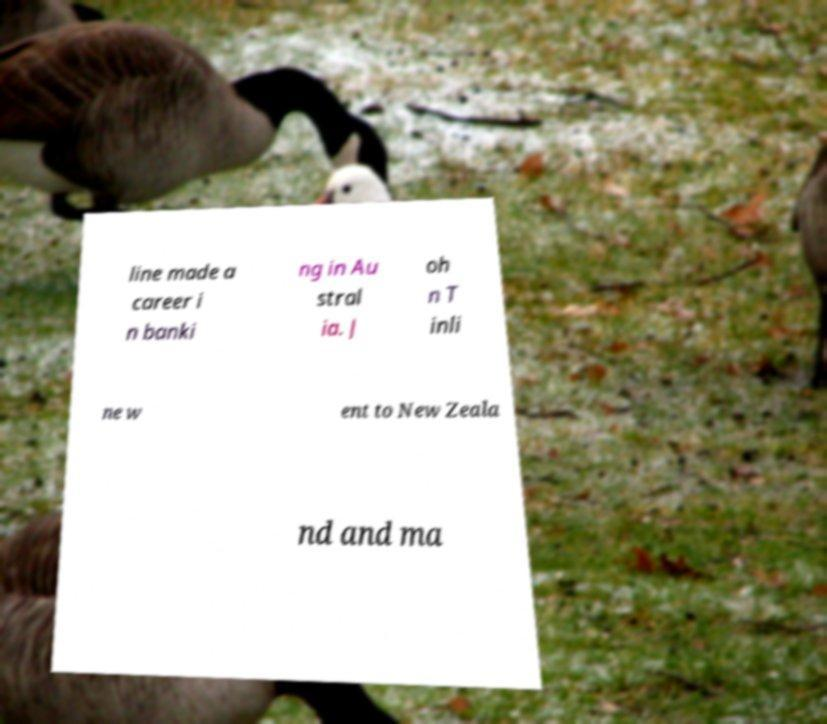For documentation purposes, I need the text within this image transcribed. Could you provide that? line made a career i n banki ng in Au stral ia. J oh n T inli ne w ent to New Zeala nd and ma 